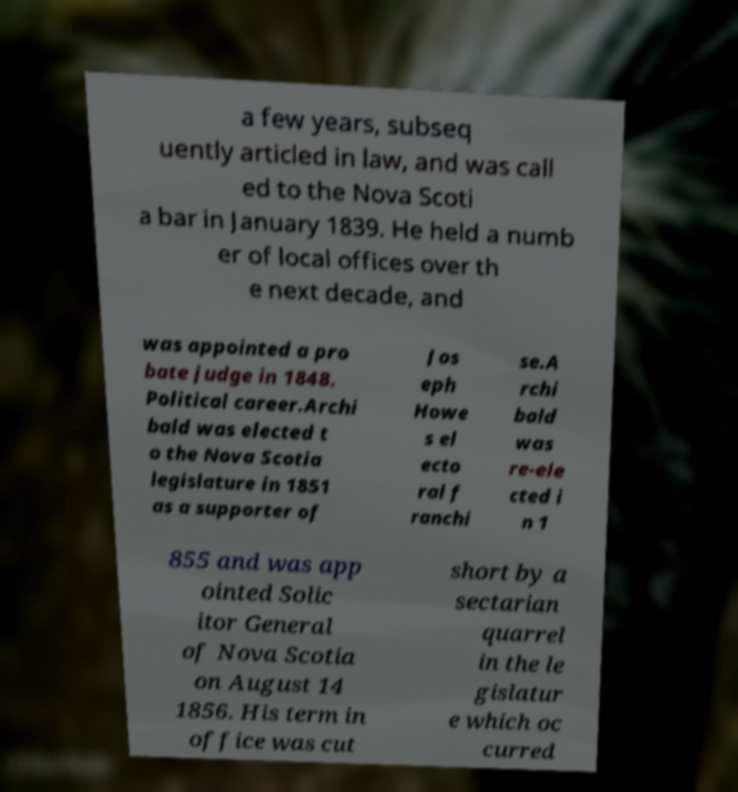For documentation purposes, I need the text within this image transcribed. Could you provide that? a few years, subseq uently articled in law, and was call ed to the Nova Scoti a bar in January 1839. He held a numb er of local offices over th e next decade, and was appointed a pro bate judge in 1848. Political career.Archi bald was elected t o the Nova Scotia legislature in 1851 as a supporter of Jos eph Howe s el ecto ral f ranchi se.A rchi bald was re-ele cted i n 1 855 and was app ointed Solic itor General of Nova Scotia on August 14 1856. His term in office was cut short by a sectarian quarrel in the le gislatur e which oc curred 